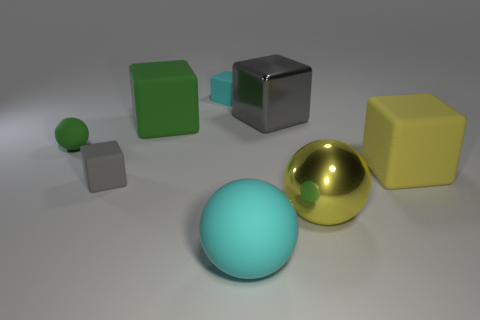There is a gray cube to the left of the cyan ball; does it have the same size as the green rubber object to the right of the tiny green ball?
Offer a very short reply. No. Is the number of large yellow matte blocks that are in front of the cyan sphere less than the number of large rubber objects that are to the right of the small cyan matte cube?
Your answer should be compact. Yes. There is a large block that is the same color as the metallic ball; what is its material?
Keep it short and to the point. Rubber. There is a small matte object to the right of the large green matte block; what color is it?
Offer a very short reply. Cyan. Is the metallic ball the same color as the big metallic cube?
Ensure brevity in your answer.  No. There is a small rubber block that is on the left side of the small rubber object right of the large green matte thing; how many tiny things are on the left side of it?
Your answer should be very brief. 1. How big is the yellow matte object?
Offer a terse response. Large. There is another green cube that is the same size as the metallic cube; what is its material?
Your response must be concise. Rubber. There is a yellow rubber cube; how many tiny cyan things are left of it?
Offer a very short reply. 1. Do the small block in front of the small cyan thing and the gray object that is behind the small green thing have the same material?
Make the answer very short. No. 